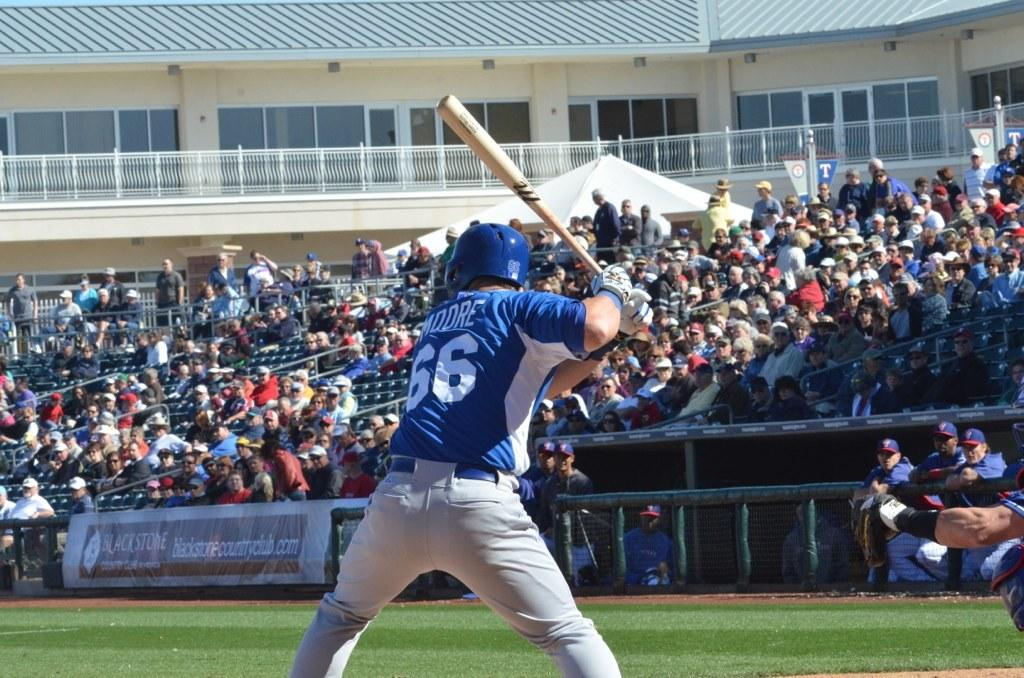<image>
Give a short and clear explanation of the subsequent image. baseball player #66 named Moore is at bat in front of crowd in the stands 